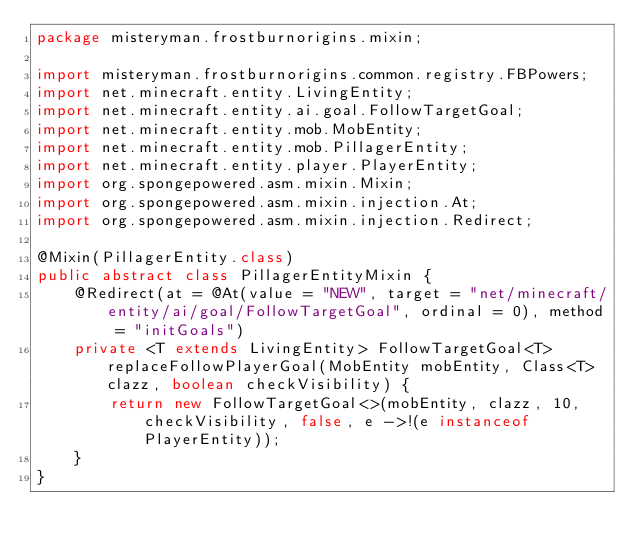<code> <loc_0><loc_0><loc_500><loc_500><_Java_>package misteryman.frostburnorigins.mixin;

import misteryman.frostburnorigins.common.registry.FBPowers;
import net.minecraft.entity.LivingEntity;
import net.minecraft.entity.ai.goal.FollowTargetGoal;
import net.minecraft.entity.mob.MobEntity;
import net.minecraft.entity.mob.PillagerEntity;
import net.minecraft.entity.player.PlayerEntity;
import org.spongepowered.asm.mixin.Mixin;
import org.spongepowered.asm.mixin.injection.At;
import org.spongepowered.asm.mixin.injection.Redirect;

@Mixin(PillagerEntity.class)
public abstract class PillagerEntityMixin {
    @Redirect(at = @At(value = "NEW", target = "net/minecraft/entity/ai/goal/FollowTargetGoal", ordinal = 0), method = "initGoals")
    private <T extends LivingEntity> FollowTargetGoal<T> replaceFollowPlayerGoal(MobEntity mobEntity, Class<T> clazz, boolean checkVisibility) {
        return new FollowTargetGoal<>(mobEntity, clazz, 10, checkVisibility, false, e ->!(e instanceof PlayerEntity));
    }
}
</code> 